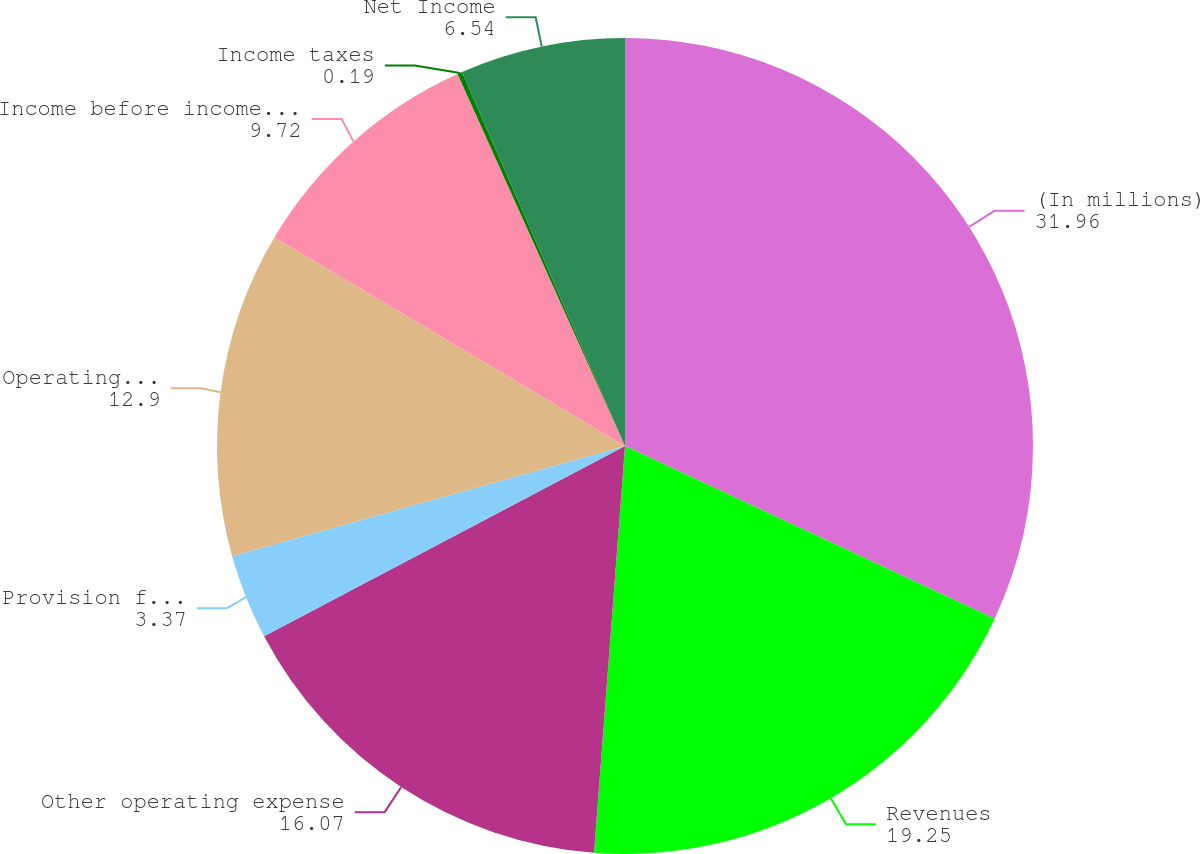Convert chart. <chart><loc_0><loc_0><loc_500><loc_500><pie_chart><fcel>(In millions)<fcel>Revenues<fcel>Other operating expense<fcel>Provision for depreciation<fcel>Operating Income<fcel>Income before income taxes<fcel>Income taxes<fcel>Net Income<nl><fcel>31.96%<fcel>19.25%<fcel>16.07%<fcel>3.37%<fcel>12.9%<fcel>9.72%<fcel>0.19%<fcel>6.54%<nl></chart> 